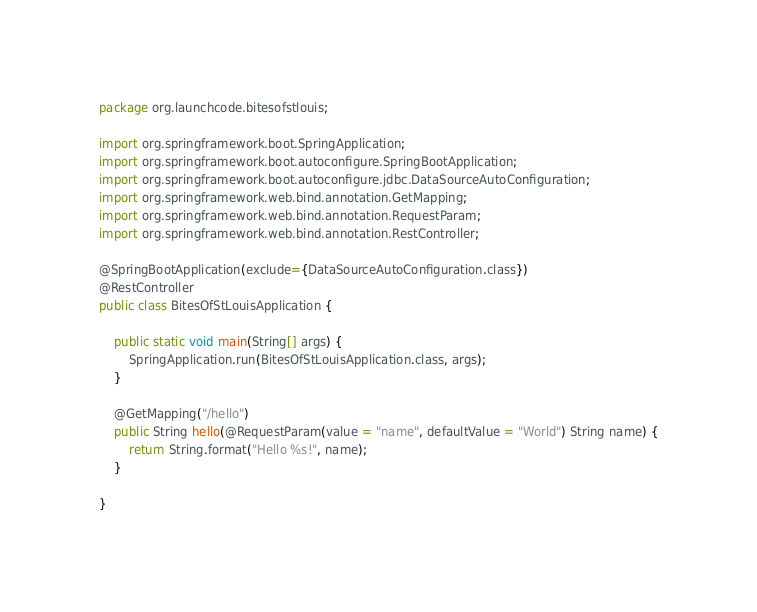<code> <loc_0><loc_0><loc_500><loc_500><_Java_>package org.launchcode.bitesofstlouis;

import org.springframework.boot.SpringApplication;
import org.springframework.boot.autoconfigure.SpringBootApplication;
import org.springframework.boot.autoconfigure.jdbc.DataSourceAutoConfiguration;
import org.springframework.web.bind.annotation.GetMapping;
import org.springframework.web.bind.annotation.RequestParam;
import org.springframework.web.bind.annotation.RestController;

@SpringBootApplication(exclude={DataSourceAutoConfiguration.class})
@RestController
public class BitesOfStLouisApplication {

	public static void main(String[] args) {
		SpringApplication.run(BitesOfStLouisApplication.class, args);
	}

	@GetMapping("/hello")
	public String hello(@RequestParam(value = "name", defaultValue = "World") String name) {
		return String.format("Hello %s!", name);
	}

}
</code> 